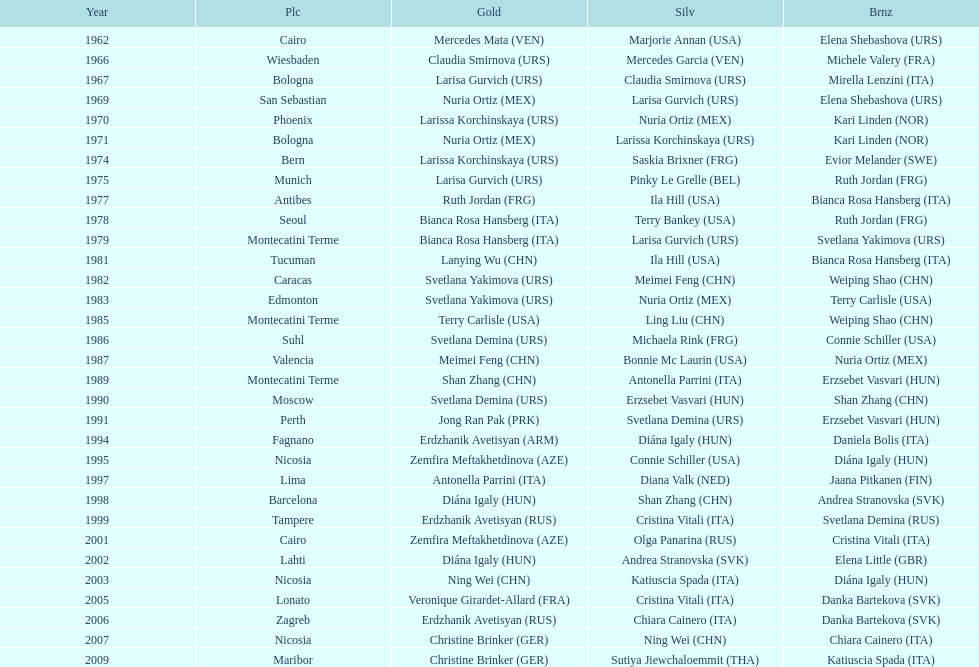Give me the full table as a dictionary. {'header': ['Year', 'Plc', 'Gold', 'Silv', 'Brnz'], 'rows': [['1962', 'Cairo', 'Mercedes Mata\xa0(VEN)', 'Marjorie Annan\xa0(USA)', 'Elena Shebashova\xa0(URS)'], ['1966', 'Wiesbaden', 'Claudia Smirnova\xa0(URS)', 'Mercedes Garcia\xa0(VEN)', 'Michele Valery\xa0(FRA)'], ['1967', 'Bologna', 'Larisa Gurvich\xa0(URS)', 'Claudia Smirnova\xa0(URS)', 'Mirella Lenzini\xa0(ITA)'], ['1969', 'San Sebastian', 'Nuria Ortiz\xa0(MEX)', 'Larisa Gurvich\xa0(URS)', 'Elena Shebashova\xa0(URS)'], ['1970', 'Phoenix', 'Larissa Korchinskaya\xa0(URS)', 'Nuria Ortiz\xa0(MEX)', 'Kari Linden\xa0(NOR)'], ['1971', 'Bologna', 'Nuria Ortiz\xa0(MEX)', 'Larissa Korchinskaya\xa0(URS)', 'Kari Linden\xa0(NOR)'], ['1974', 'Bern', 'Larissa Korchinskaya\xa0(URS)', 'Saskia Brixner\xa0(FRG)', 'Evior Melander\xa0(SWE)'], ['1975', 'Munich', 'Larisa Gurvich\xa0(URS)', 'Pinky Le Grelle\xa0(BEL)', 'Ruth Jordan\xa0(FRG)'], ['1977', 'Antibes', 'Ruth Jordan\xa0(FRG)', 'Ila Hill\xa0(USA)', 'Bianca Rosa Hansberg\xa0(ITA)'], ['1978', 'Seoul', 'Bianca Rosa Hansberg\xa0(ITA)', 'Terry Bankey\xa0(USA)', 'Ruth Jordan\xa0(FRG)'], ['1979', 'Montecatini Terme', 'Bianca Rosa Hansberg\xa0(ITA)', 'Larisa Gurvich\xa0(URS)', 'Svetlana Yakimova\xa0(URS)'], ['1981', 'Tucuman', 'Lanying Wu\xa0(CHN)', 'Ila Hill\xa0(USA)', 'Bianca Rosa Hansberg\xa0(ITA)'], ['1982', 'Caracas', 'Svetlana Yakimova\xa0(URS)', 'Meimei Feng\xa0(CHN)', 'Weiping Shao\xa0(CHN)'], ['1983', 'Edmonton', 'Svetlana Yakimova\xa0(URS)', 'Nuria Ortiz\xa0(MEX)', 'Terry Carlisle\xa0(USA)'], ['1985', 'Montecatini Terme', 'Terry Carlisle\xa0(USA)', 'Ling Liu\xa0(CHN)', 'Weiping Shao\xa0(CHN)'], ['1986', 'Suhl', 'Svetlana Demina\xa0(URS)', 'Michaela Rink\xa0(FRG)', 'Connie Schiller\xa0(USA)'], ['1987', 'Valencia', 'Meimei Feng\xa0(CHN)', 'Bonnie Mc Laurin\xa0(USA)', 'Nuria Ortiz\xa0(MEX)'], ['1989', 'Montecatini Terme', 'Shan Zhang\xa0(CHN)', 'Antonella Parrini\xa0(ITA)', 'Erzsebet Vasvari\xa0(HUN)'], ['1990', 'Moscow', 'Svetlana Demina\xa0(URS)', 'Erzsebet Vasvari\xa0(HUN)', 'Shan Zhang\xa0(CHN)'], ['1991', 'Perth', 'Jong Ran Pak\xa0(PRK)', 'Svetlana Demina\xa0(URS)', 'Erzsebet Vasvari\xa0(HUN)'], ['1994', 'Fagnano', 'Erdzhanik Avetisyan\xa0(ARM)', 'Diána Igaly\xa0(HUN)', 'Daniela Bolis\xa0(ITA)'], ['1995', 'Nicosia', 'Zemfira Meftakhetdinova\xa0(AZE)', 'Connie Schiller\xa0(USA)', 'Diána Igaly\xa0(HUN)'], ['1997', 'Lima', 'Antonella Parrini\xa0(ITA)', 'Diana Valk\xa0(NED)', 'Jaana Pitkanen\xa0(FIN)'], ['1998', 'Barcelona', 'Diána Igaly\xa0(HUN)', 'Shan Zhang\xa0(CHN)', 'Andrea Stranovska\xa0(SVK)'], ['1999', 'Tampere', 'Erdzhanik Avetisyan\xa0(RUS)', 'Cristina Vitali\xa0(ITA)', 'Svetlana Demina\xa0(RUS)'], ['2001', 'Cairo', 'Zemfira Meftakhetdinova\xa0(AZE)', 'Olga Panarina\xa0(RUS)', 'Cristina Vitali\xa0(ITA)'], ['2002', 'Lahti', 'Diána Igaly\xa0(HUN)', 'Andrea Stranovska\xa0(SVK)', 'Elena Little\xa0(GBR)'], ['2003', 'Nicosia', 'Ning Wei\xa0(CHN)', 'Katiuscia Spada\xa0(ITA)', 'Diána Igaly\xa0(HUN)'], ['2005', 'Lonato', 'Veronique Girardet-Allard\xa0(FRA)', 'Cristina Vitali\xa0(ITA)', 'Danka Bartekova\xa0(SVK)'], ['2006', 'Zagreb', 'Erdzhanik Avetisyan\xa0(RUS)', 'Chiara Cainero\xa0(ITA)', 'Danka Bartekova\xa0(SVK)'], ['2007', 'Nicosia', 'Christine Brinker\xa0(GER)', 'Ning Wei\xa0(CHN)', 'Chiara Cainero\xa0(ITA)'], ['2009', 'Maribor', 'Christine Brinker\xa0(GER)', 'Sutiya Jiewchaloemmit\xa0(THA)', 'Katiuscia Spada\xa0(ITA)']]} What is the total of silver for cairo 0. 